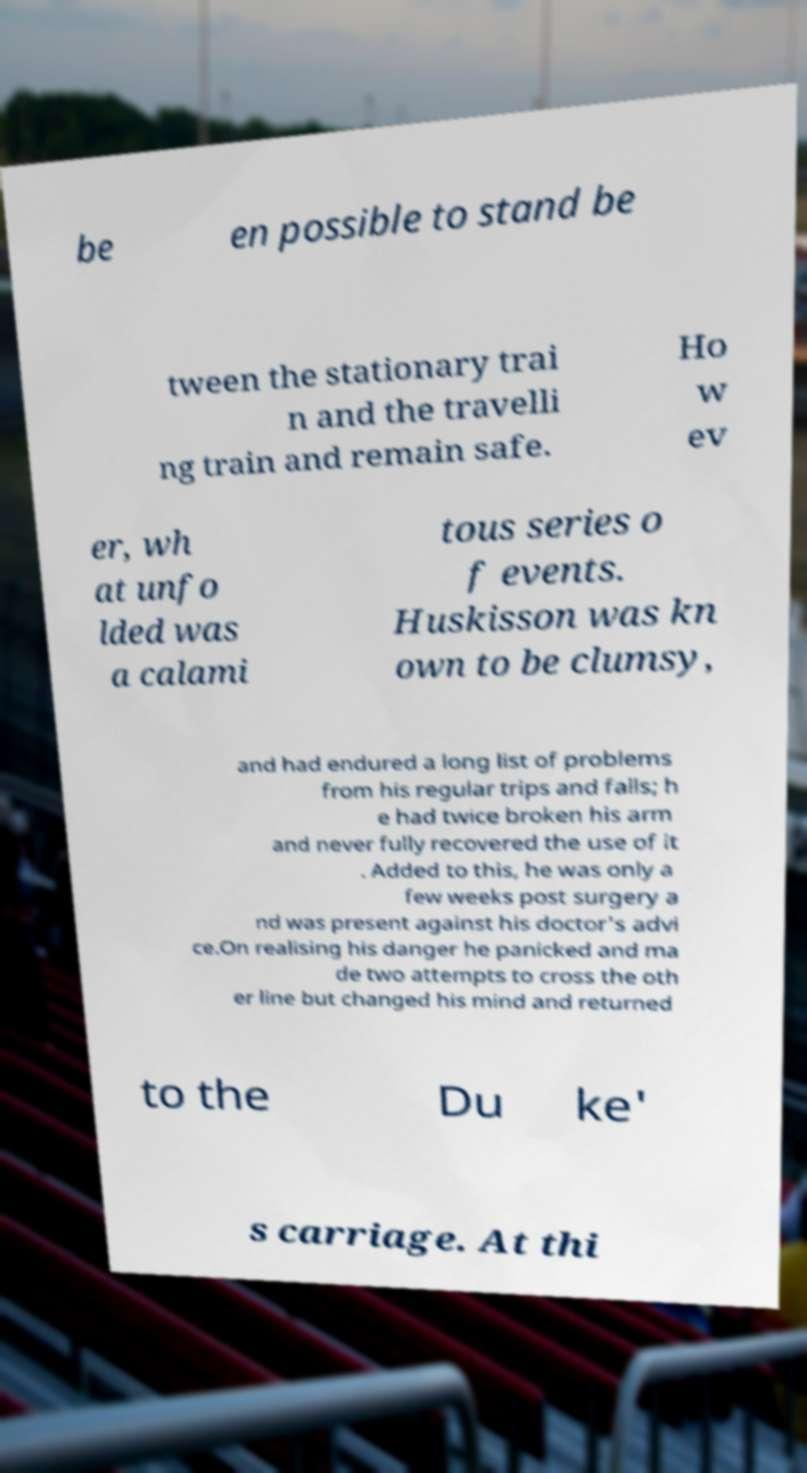What messages or text are displayed in this image? I need them in a readable, typed format. be en possible to stand be tween the stationary trai n and the travelli ng train and remain safe. Ho w ev er, wh at unfo lded was a calami tous series o f events. Huskisson was kn own to be clumsy, and had endured a long list of problems from his regular trips and falls; h e had twice broken his arm and never fully recovered the use of it . Added to this, he was only a few weeks post surgery a nd was present against his doctor's advi ce.On realising his danger he panicked and ma de two attempts to cross the oth er line but changed his mind and returned to the Du ke' s carriage. At thi 